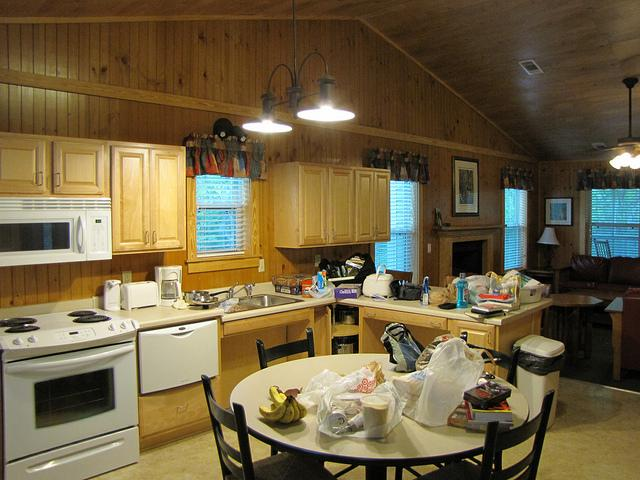What is on top of the dining table?

Choices:
A) cat
B) bananas
C) fish heads
D) yule log bananas 